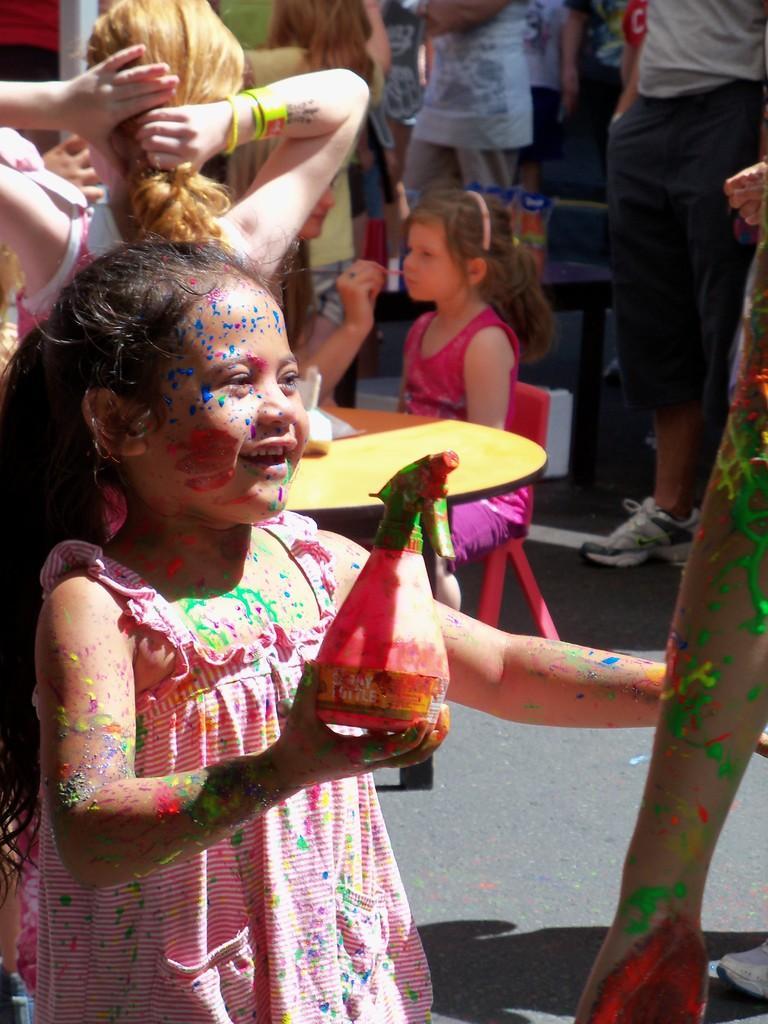Describe this image in one or two sentences. In this image there is a girl and holding a bottle in her hand. A girl is sitting on a chair before a bench. A person is holding a brush in his hand. Few persons are standing on the floor. Right side a person hand is visible. 